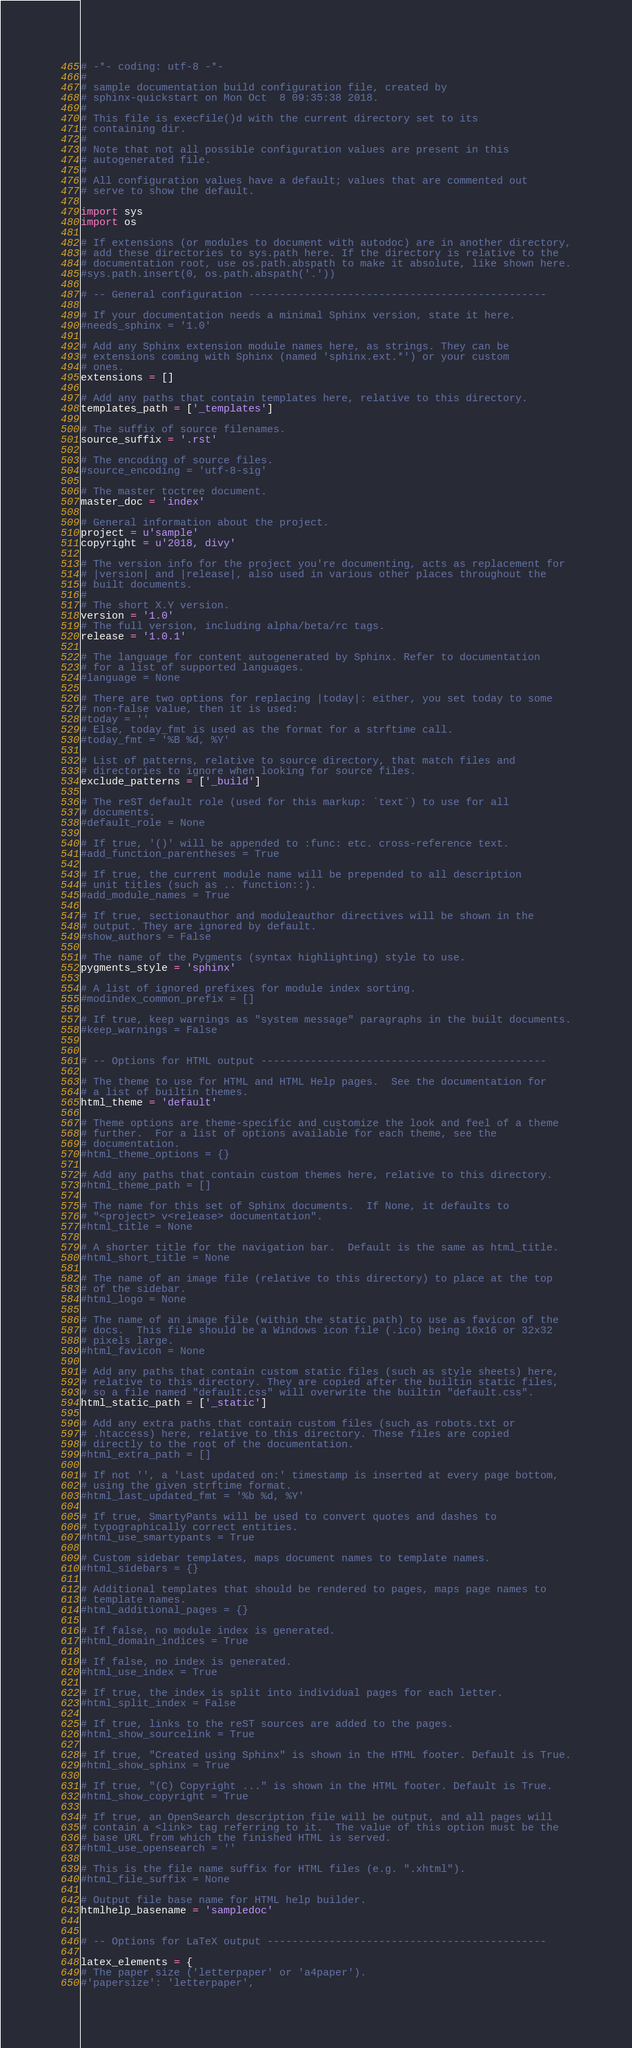Convert code to text. <code><loc_0><loc_0><loc_500><loc_500><_Python_># -*- coding: utf-8 -*-
#
# sample documentation build configuration file, created by
# sphinx-quickstart on Mon Oct  8 09:35:38 2018.
#
# This file is execfile()d with the current directory set to its
# containing dir.
#
# Note that not all possible configuration values are present in this
# autogenerated file.
#
# All configuration values have a default; values that are commented out
# serve to show the default.

import sys
import os

# If extensions (or modules to document with autodoc) are in another directory,
# add these directories to sys.path here. If the directory is relative to the
# documentation root, use os.path.abspath to make it absolute, like shown here.
#sys.path.insert(0, os.path.abspath('.'))

# -- General configuration ------------------------------------------------

# If your documentation needs a minimal Sphinx version, state it here.
#needs_sphinx = '1.0'

# Add any Sphinx extension module names here, as strings. They can be
# extensions coming with Sphinx (named 'sphinx.ext.*') or your custom
# ones.
extensions = []

# Add any paths that contain templates here, relative to this directory.
templates_path = ['_templates']

# The suffix of source filenames.
source_suffix = '.rst'

# The encoding of source files.
#source_encoding = 'utf-8-sig'

# The master toctree document.
master_doc = 'index'

# General information about the project.
project = u'sample'
copyright = u'2018, divy'

# The version info for the project you're documenting, acts as replacement for
# |version| and |release|, also used in various other places throughout the
# built documents.
#
# The short X.Y version.
version = '1.0'
# The full version, including alpha/beta/rc tags.
release = '1.0.1'

# The language for content autogenerated by Sphinx. Refer to documentation
# for a list of supported languages.
#language = None

# There are two options for replacing |today|: either, you set today to some
# non-false value, then it is used:
#today = ''
# Else, today_fmt is used as the format for a strftime call.
#today_fmt = '%B %d, %Y'

# List of patterns, relative to source directory, that match files and
# directories to ignore when looking for source files.
exclude_patterns = ['_build']

# The reST default role (used for this markup: `text`) to use for all
# documents.
#default_role = None

# If true, '()' will be appended to :func: etc. cross-reference text.
#add_function_parentheses = True

# If true, the current module name will be prepended to all description
# unit titles (such as .. function::).
#add_module_names = True

# If true, sectionauthor and moduleauthor directives will be shown in the
# output. They are ignored by default.
#show_authors = False

# The name of the Pygments (syntax highlighting) style to use.
pygments_style = 'sphinx'

# A list of ignored prefixes for module index sorting.
#modindex_common_prefix = []

# If true, keep warnings as "system message" paragraphs in the built documents.
#keep_warnings = False


# -- Options for HTML output ----------------------------------------------

# The theme to use for HTML and HTML Help pages.  See the documentation for
# a list of builtin themes.
html_theme = 'default'

# Theme options are theme-specific and customize the look and feel of a theme
# further.  For a list of options available for each theme, see the
# documentation.
#html_theme_options = {}

# Add any paths that contain custom themes here, relative to this directory.
#html_theme_path = []

# The name for this set of Sphinx documents.  If None, it defaults to
# "<project> v<release> documentation".
#html_title = None

# A shorter title for the navigation bar.  Default is the same as html_title.
#html_short_title = None

# The name of an image file (relative to this directory) to place at the top
# of the sidebar.
#html_logo = None

# The name of an image file (within the static path) to use as favicon of the
# docs.  This file should be a Windows icon file (.ico) being 16x16 or 32x32
# pixels large.
#html_favicon = None

# Add any paths that contain custom static files (such as style sheets) here,
# relative to this directory. They are copied after the builtin static files,
# so a file named "default.css" will overwrite the builtin "default.css".
html_static_path = ['_static']

# Add any extra paths that contain custom files (such as robots.txt or
# .htaccess) here, relative to this directory. These files are copied
# directly to the root of the documentation.
#html_extra_path = []

# If not '', a 'Last updated on:' timestamp is inserted at every page bottom,
# using the given strftime format.
#html_last_updated_fmt = '%b %d, %Y'

# If true, SmartyPants will be used to convert quotes and dashes to
# typographically correct entities.
#html_use_smartypants = True

# Custom sidebar templates, maps document names to template names.
#html_sidebars = {}

# Additional templates that should be rendered to pages, maps page names to
# template names.
#html_additional_pages = {}

# If false, no module index is generated.
#html_domain_indices = True

# If false, no index is generated.
#html_use_index = True

# If true, the index is split into individual pages for each letter.
#html_split_index = False

# If true, links to the reST sources are added to the pages.
#html_show_sourcelink = True

# If true, "Created using Sphinx" is shown in the HTML footer. Default is True.
#html_show_sphinx = True

# If true, "(C) Copyright ..." is shown in the HTML footer. Default is True.
#html_show_copyright = True

# If true, an OpenSearch description file will be output, and all pages will
# contain a <link> tag referring to it.  The value of this option must be the
# base URL from which the finished HTML is served.
#html_use_opensearch = ''

# This is the file name suffix for HTML files (e.g. ".xhtml").
#html_file_suffix = None

# Output file base name for HTML help builder.
htmlhelp_basename = 'sampledoc'


# -- Options for LaTeX output ---------------------------------------------

latex_elements = {
# The paper size ('letterpaper' or 'a4paper').
#'papersize': 'letterpaper',
</code> 